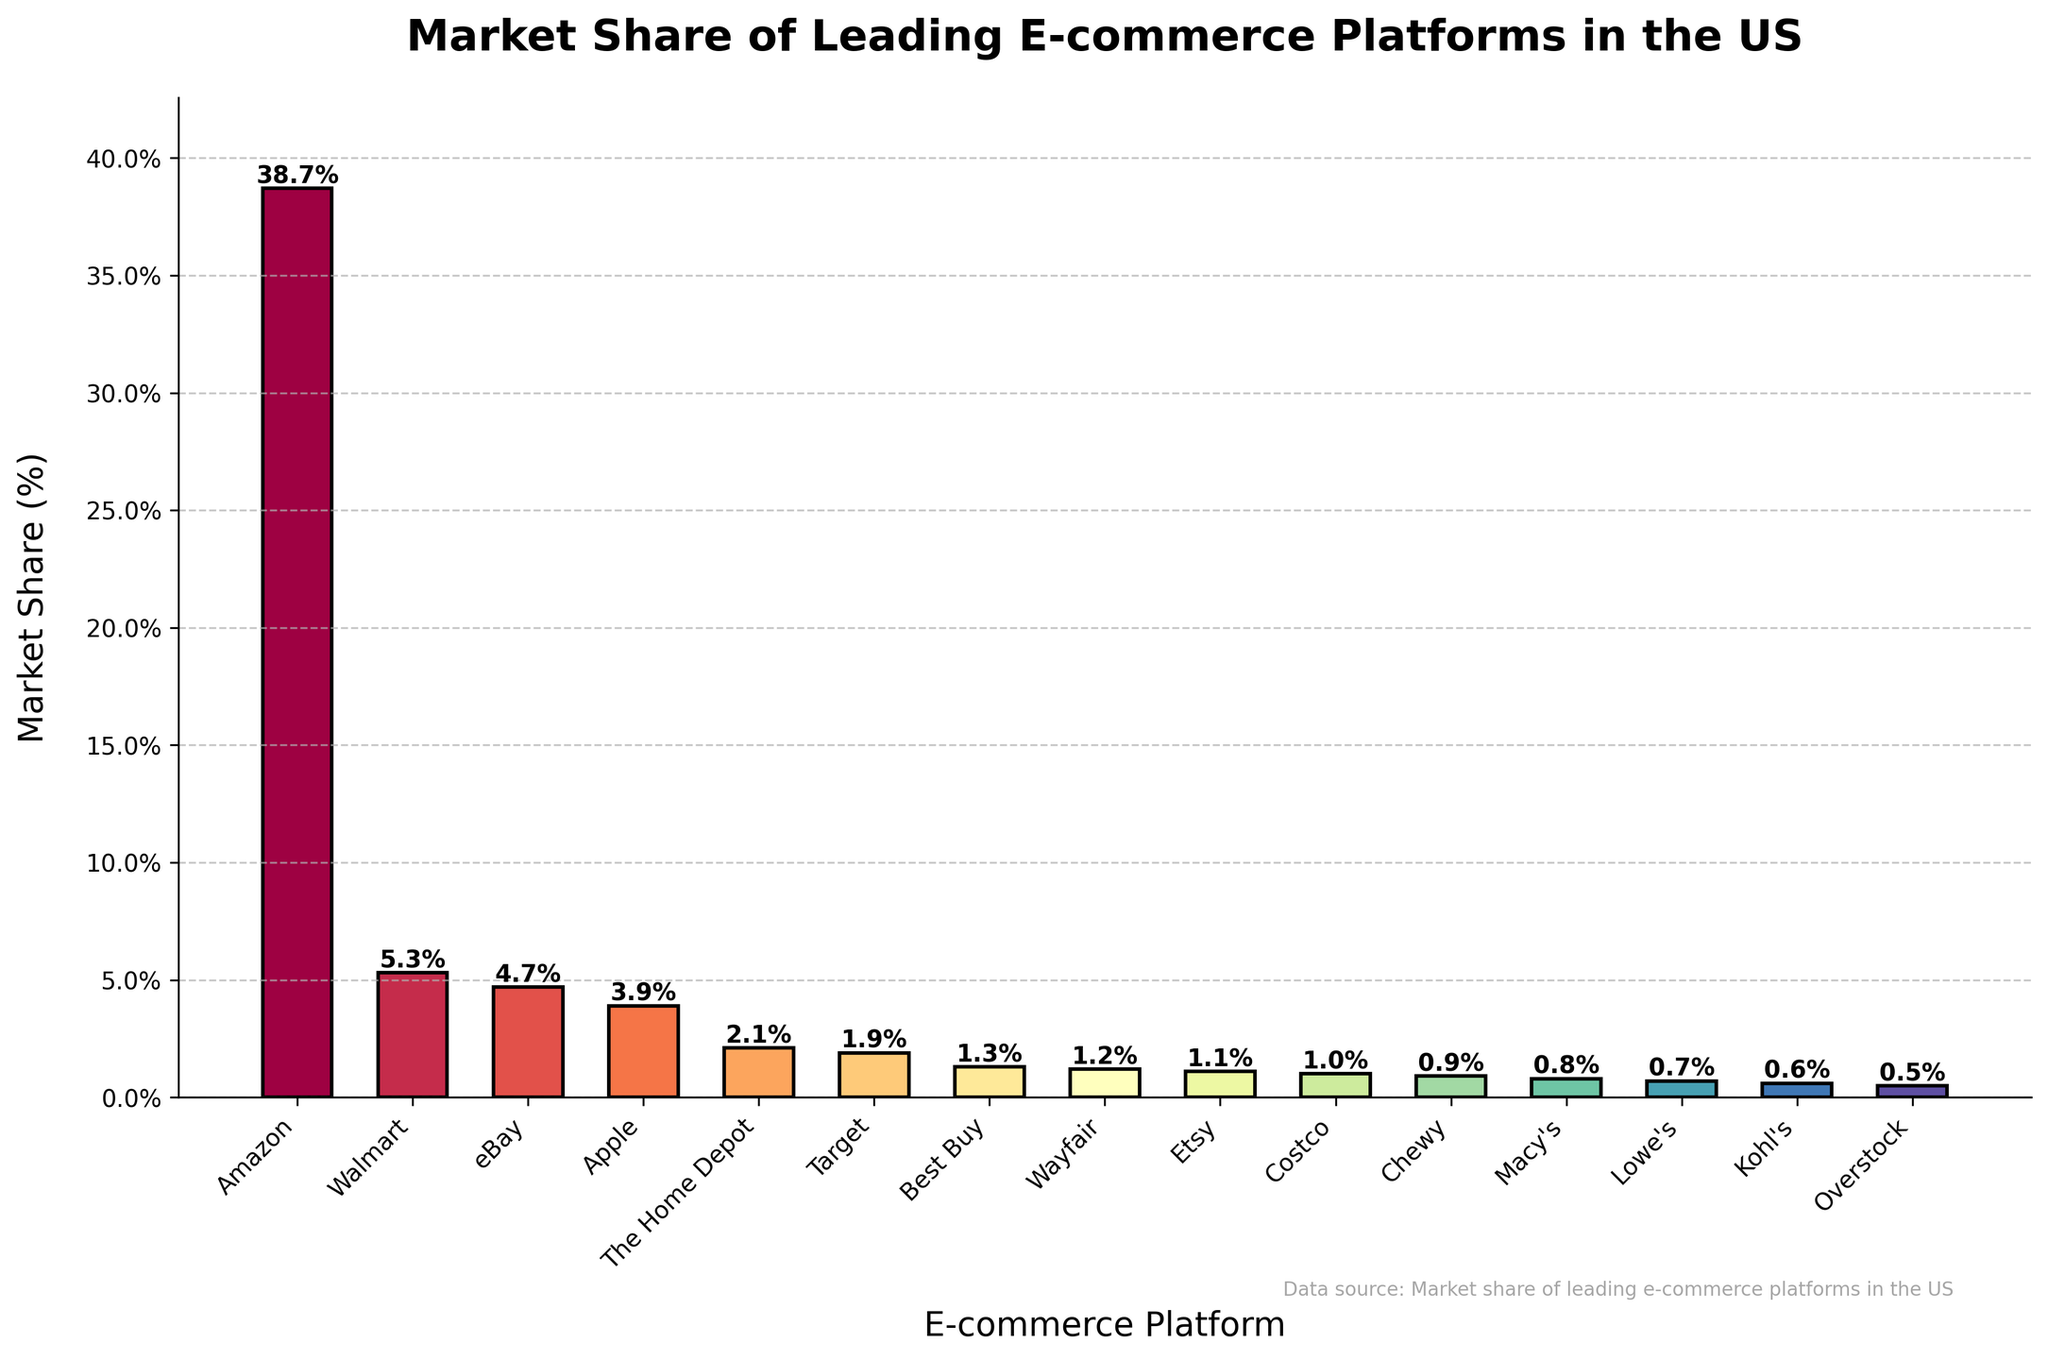What is the market share of Amazon? By looking at the height of the bar labeled "Amazon" on the chart, we can see it is the tallest bar, indicating the highest market share. The label on top of the bar shows "38.7%."
Answer: 38.7% Which e-commerce platform has the second-largest market share? The second tallest bar after Amazon's belongs to Walmart, with a market share label showing "5.3%."
Answer: Walmart How much greater is Amazon's market share compared to eBay's? Amazon's market share is 38.7% and eBay's is 4.7%. The difference is 38.7% - 4.7% = 34%.
Answer: 34% What is the combined market share of Apple, The Home Depot, and Target? Add the market shares of Apple (3.9%), The Home Depot (2.1%), and Target (1.9%): 3.9% + 2.1% + 1.9% = 7.9%.
Answer: 7.9% How many platforms have a market share of less than 1%? The bars for Wayfair, Etsy, Costco, Chewy, Macy's, Lowe's, Kohl's, and Overstock are all below 1%. There are 8 such platforms.
Answer: 8 What is the color associated with the e-commerce platform Target in the bar chart? By observing the color spectrum used in the chart, we know each bar has a unique color. The color associated with Target can be identified by looking at the specific bar labeled "Target."
Answer: (Here, a specific color name description based on the visual could be given, but exact color names can vary.) Which platform has the smallest market share, and what is its value? The shortest bar on the chart belongs to Overstock with a market share label showing "0.5%."
Answer: Overstock, 0.5% Compare the market shares of The Home Depot and Best Buy. Which one has a higher market share and by how much? The Home Depot has 2.1% and Best Buy has 1.3%. The Home Depot's market share is higher by 2.1% - 1.3% = 0.8%.
Answer: The Home Depot, 0.8% What is the average market share of Walmart, eBay, and Apple? Add the market shares of Walmart (5.3%), eBay (4.7%), and Apple (3.9%) and then divide by 3: (5.3% + 4.7% + 3.9%) / 3 ≈ 4.63%.
Answer: 4.63% Which e-commerce platforms have a market share greater than or equal to 2% but less than 5%? By looking at the chart, the platforms in this range are Walmart (5.3%), eBay (4.7%), and Apple (3.9%). The Home Depot (2.1%) is also included as it meets the lower limit.
Answer: Walmart, eBay, Apple, The Home Depot 